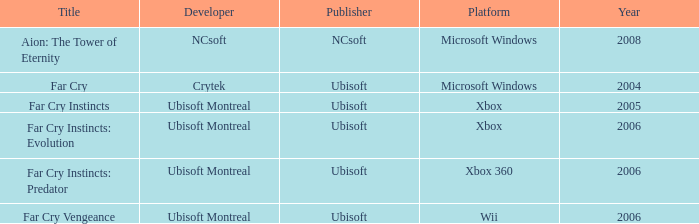What is the average year that has far cry vengeance as the title? 2006.0. 